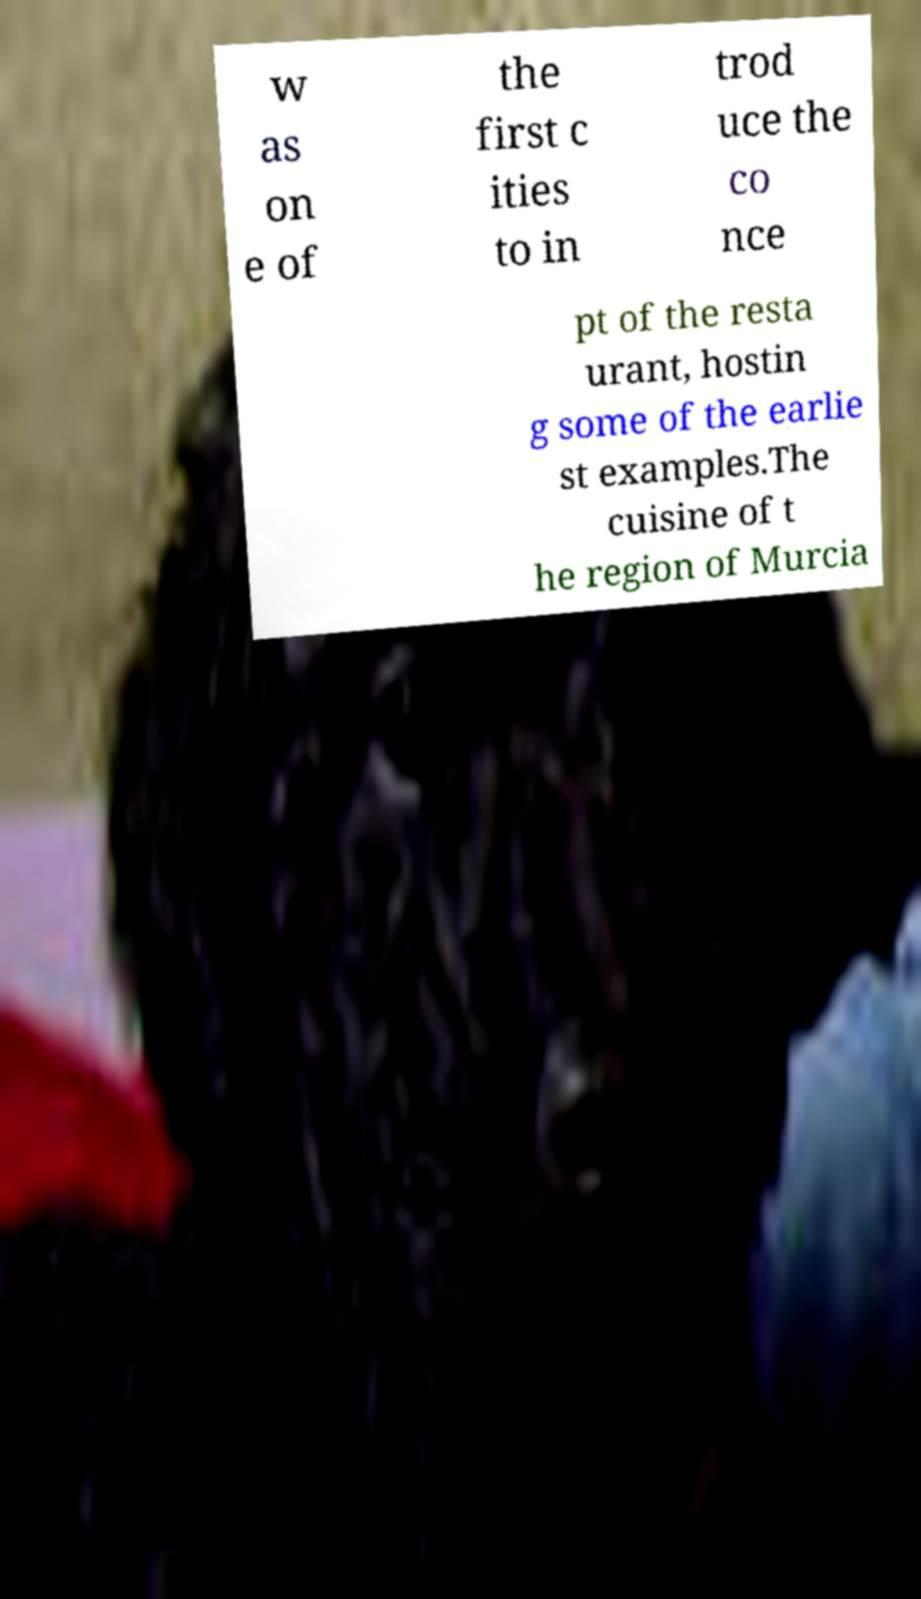Could you extract and type out the text from this image? w as on e of the first c ities to in trod uce the co nce pt of the resta urant, hostin g some of the earlie st examples.The cuisine of t he region of Murcia 